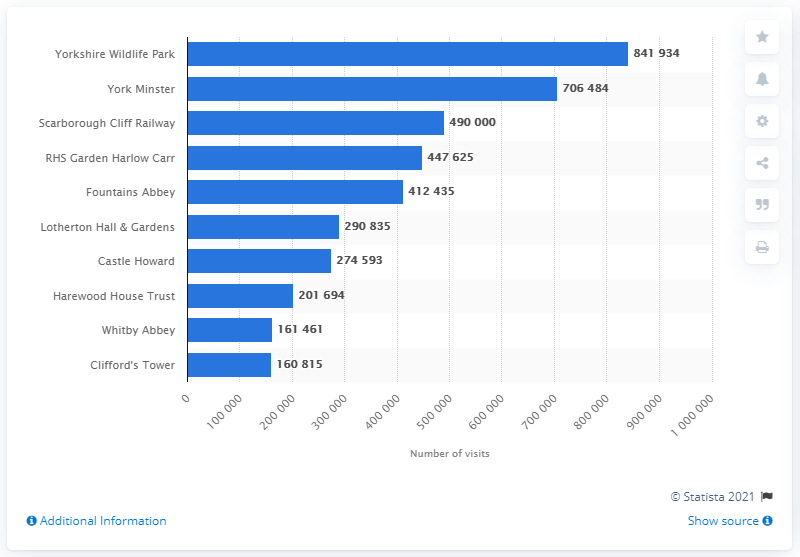Point out several critical features in this image. In the Yorkshire and Humberside region in 2019, the leading attraction was Yorkshire Wildlife Park, which was very popular among visitors. In 2019, a total of 841,934 people visited Yorkshire Wildlife Park. 